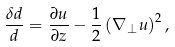Convert formula to latex. <formula><loc_0><loc_0><loc_500><loc_500>\frac { \delta d } { d } = \frac { \partial u } { \partial z } - \frac { 1 } { 2 } \left ( \nabla _ { \perp } u \right ) ^ { 2 } ,</formula> 